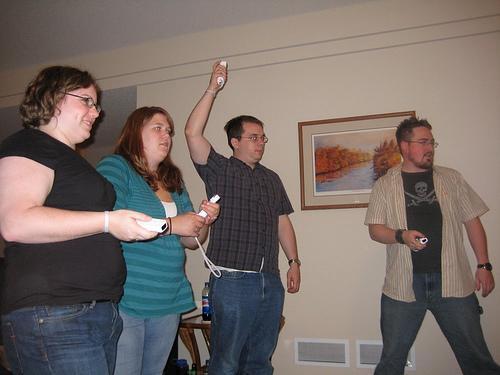How many people are standing?
Give a very brief answer. 4. How many women are playing?
Give a very brief answer. 2. How many people are playing the game?
Give a very brief answer. 4. How many people wearing blue jeans?
Give a very brief answer. 4. How many people are visible?
Give a very brief answer. 4. How many people are wearing a tie in the picture?
Give a very brief answer. 0. 